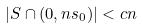<formula> <loc_0><loc_0><loc_500><loc_500>| S \cap ( 0 , n s _ { 0 } ) | < c n</formula> 